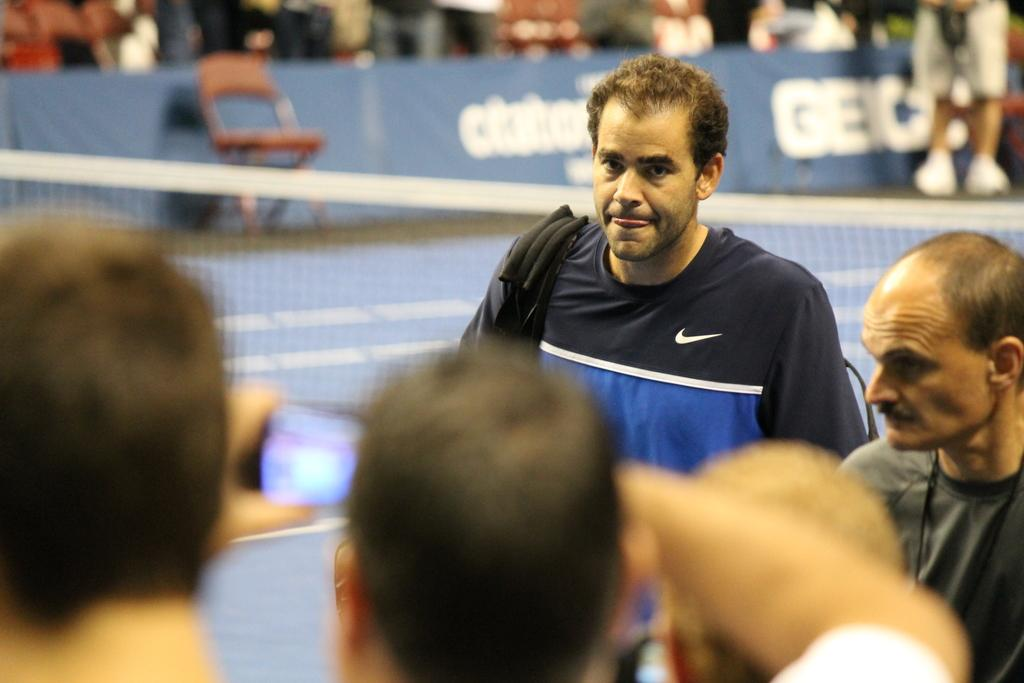How many people are visible in the image? There are many persons standing on the ground. What can be seen in the background of the image? There is a net and at least one chair in the background. Are there any other people in the background? Yes, there are additional persons in the background. What type of lace is being used to hold the group together in the image? There is no lace present in the image; the people are standing independently. How many fingers does the person in the front have on their right hand? The image does not provide enough detail to determine the number of fingers on any person's hand. 